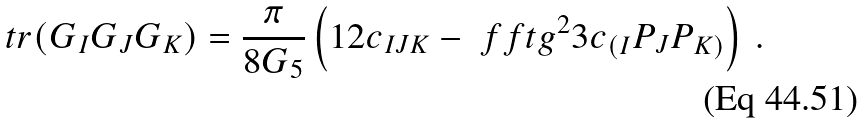<formula> <loc_0><loc_0><loc_500><loc_500>t r ( G _ { I } G _ { J } G _ { K } ) = \frac { \pi } { 8 G _ { 5 } } \left ( 1 2 c _ { I J K } - \ f f t { g ^ { 2 } } 3 c _ { ( I } P _ { J } P _ { K ) } \right ) \, .</formula> 